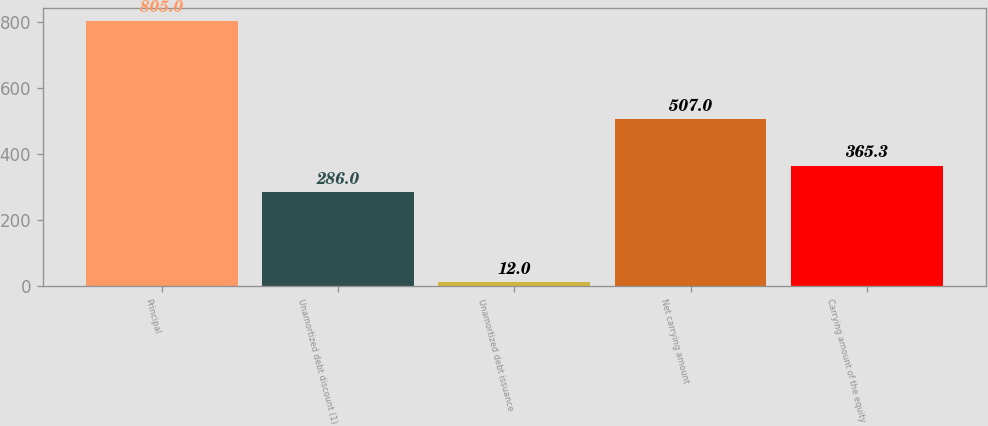<chart> <loc_0><loc_0><loc_500><loc_500><bar_chart><fcel>Principal<fcel>Unamortized debt discount (1)<fcel>Unamortized debt issuance<fcel>Net carrying amount<fcel>Carrying amount of the equity<nl><fcel>805<fcel>286<fcel>12<fcel>507<fcel>365.3<nl></chart> 